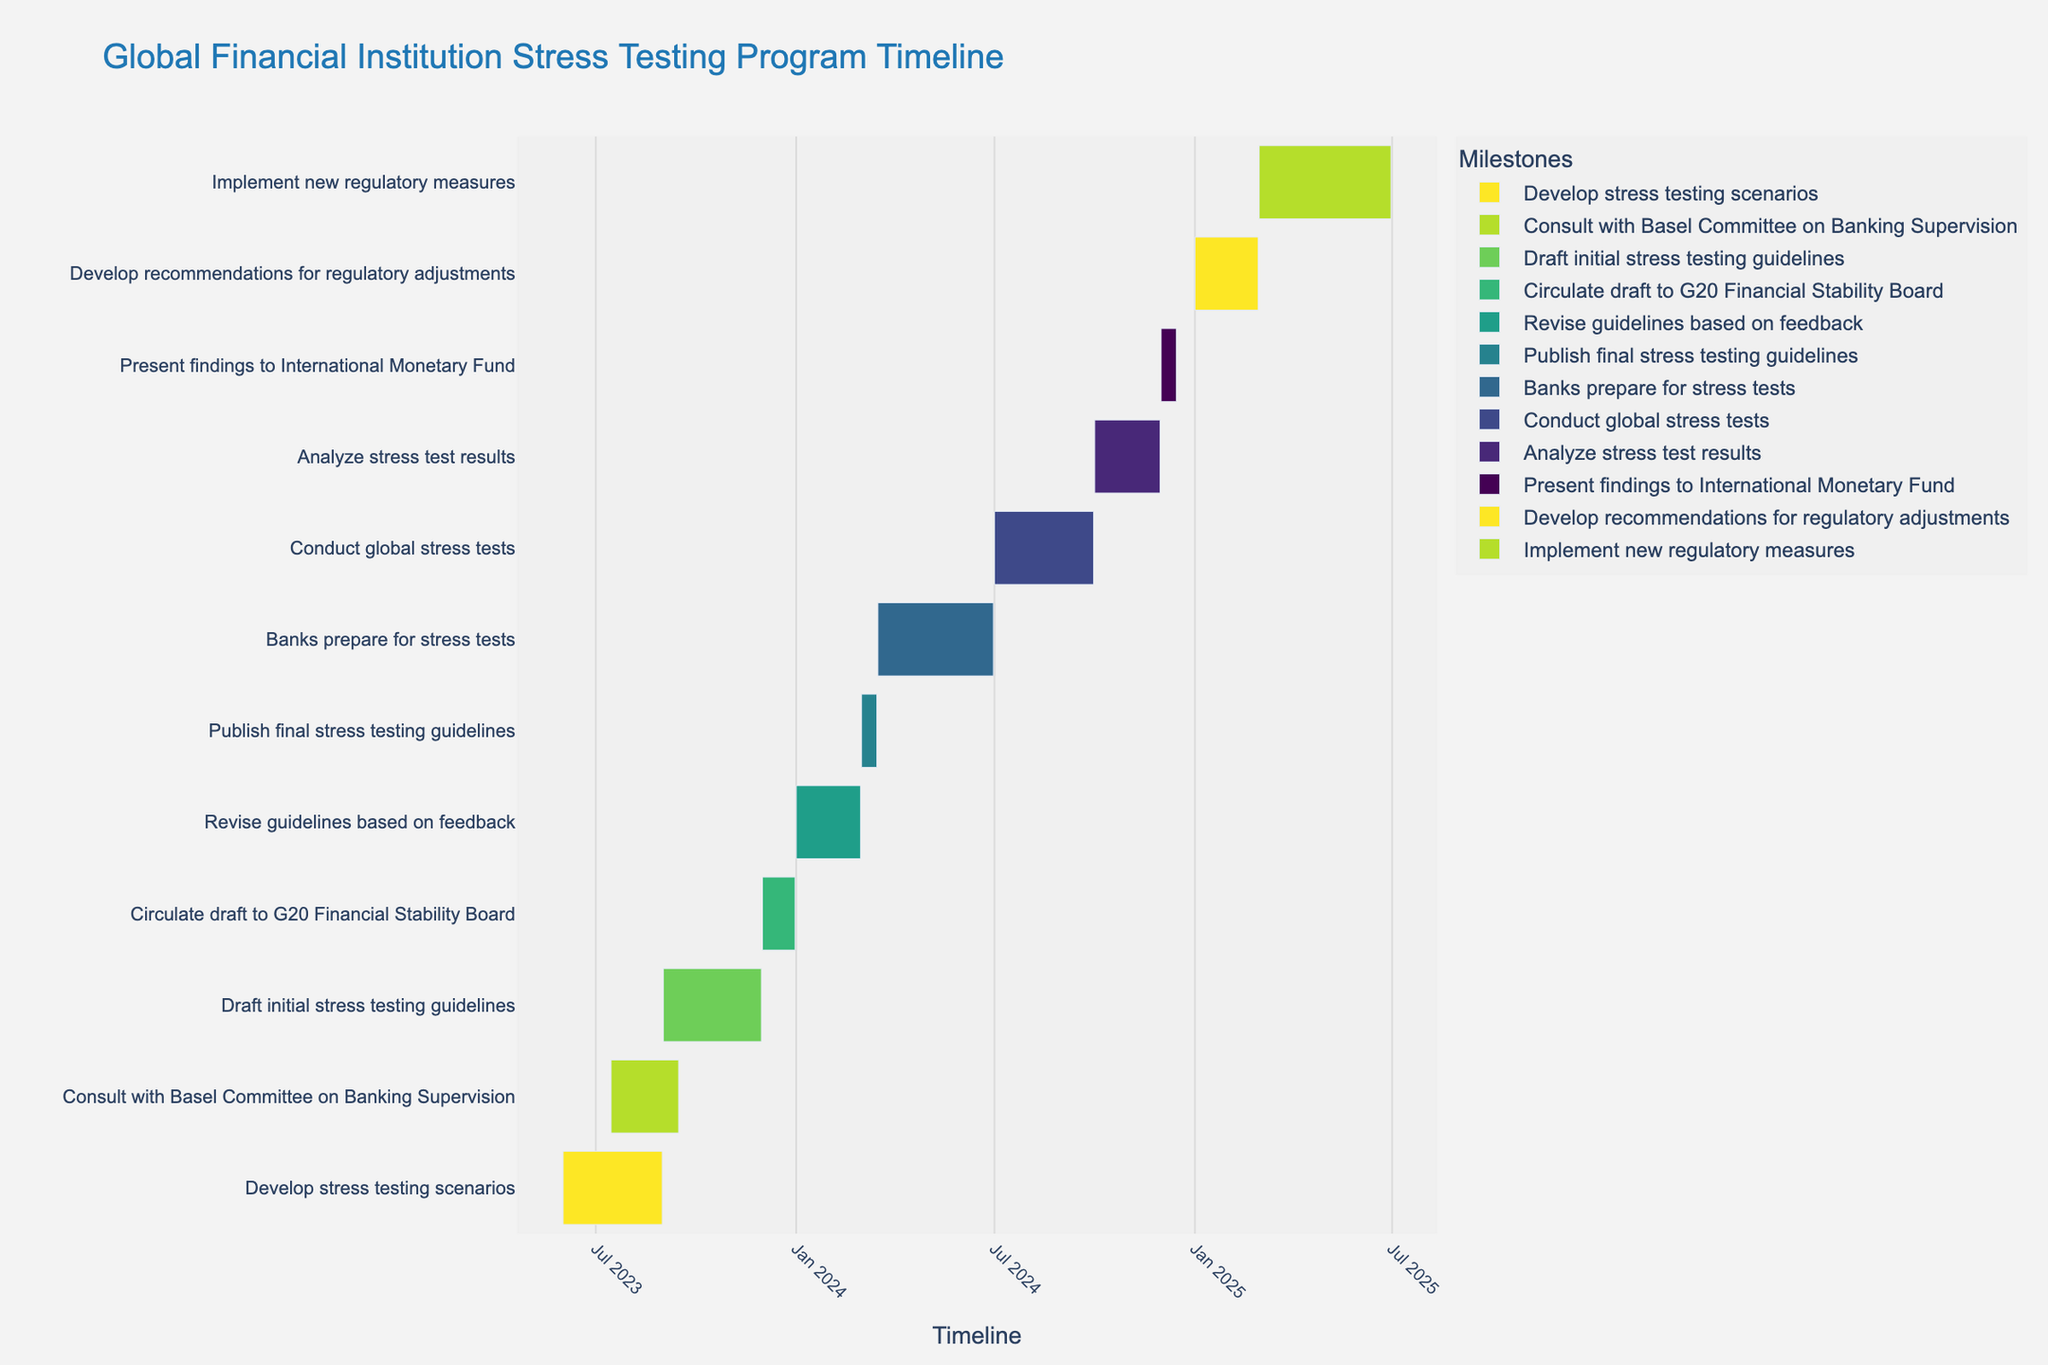What is the title of the Gantt chart? The title of the Gantt chart is located at the top center of the chart and is typically in a larger, bold font compared to other text on the figure.
Answer: Global Financial Institution Stress Testing Program Timeline Which task starts first and which one starts last? To determine this, look at the timeline on the horizontal axis. The task that has its starting point furthest to the left starts first, and the task with its starting point furthest to the right starts last.
Answer: First: Develop stress testing scenarios, Last: Develop recommendations for regulatory adjustments How long does the task "Conduct global stress tests" last? Locate the task "Conduct global stress tests" on the y-axis and check the start and end dates along the x-axis. Subtract the start date from the end date to find the duration.
Answer: 3 months (July 1, 2024, to September 30, 2024) Which tasks overlap with the consultation with the Basel Committee on Banking Supervision? Identify the start and end dates of "Consult with Basel Committee on Banking Supervision" (July 15, 2023, to September 15, 2023). Any task that has dates within this range overlaps.
Answer: Develop stress testing scenarios, Draft initial stress testing guidelines What’s the duration of the entire program from the first task to the last task? Look at the start date of the first task (June 1, 2023) and the end date of the last task (June 30, 2025). Calculate the duration from the first start date to the final end date.
Answer: 25 months (June 1, 2023, to June 30, 2025) Which task has the shortest duration? Review each task’s start and end dates to compute their durations. Identify the task with the smallest time span.
Answer: Publish final stress testing guidelines How many tasks are scheduled to start in 2024? Count the number of tasks that have their start date within the year 2024.
Answer: 4 tasks When do banks start preparing for stress tests? Find the task "Banks prepare for stress tests" on the y-axis and check its start date on the x-axis.
Answer: March 16, 2024 Which task has the longest duration, and how many days does it last? Calculate the duration of each task by subtracting the start date from the end date. The task with the longest time span is the required answer.
Answer: Implement new regulatory measures, 122 days (March 1, 2025, to June 30, 2025) During which month in 2024 do most of the tasks take place? Count the number of tasks that are active each month in 2024 by examining their start and end dates.
Answer: December 